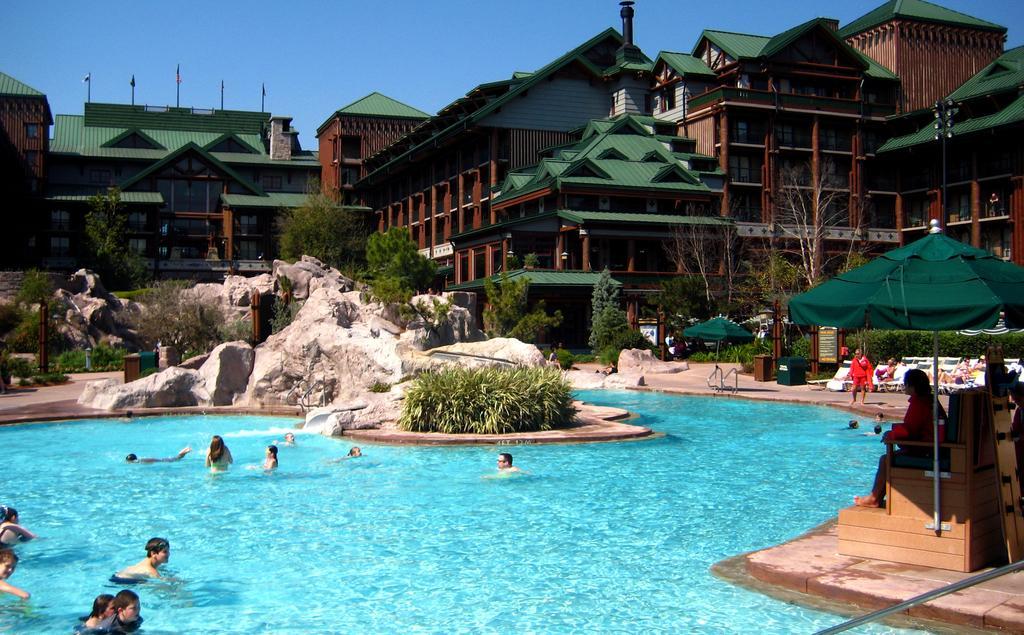Can you describe this image briefly? In the center of the image there is a swimming pool. There are people in it. In the background of the image there are houses. There are trees. There is a stone. To the right side of the image there is a person sitting on a chair. On top of him there is a umbrella. At the top image there is sky. 